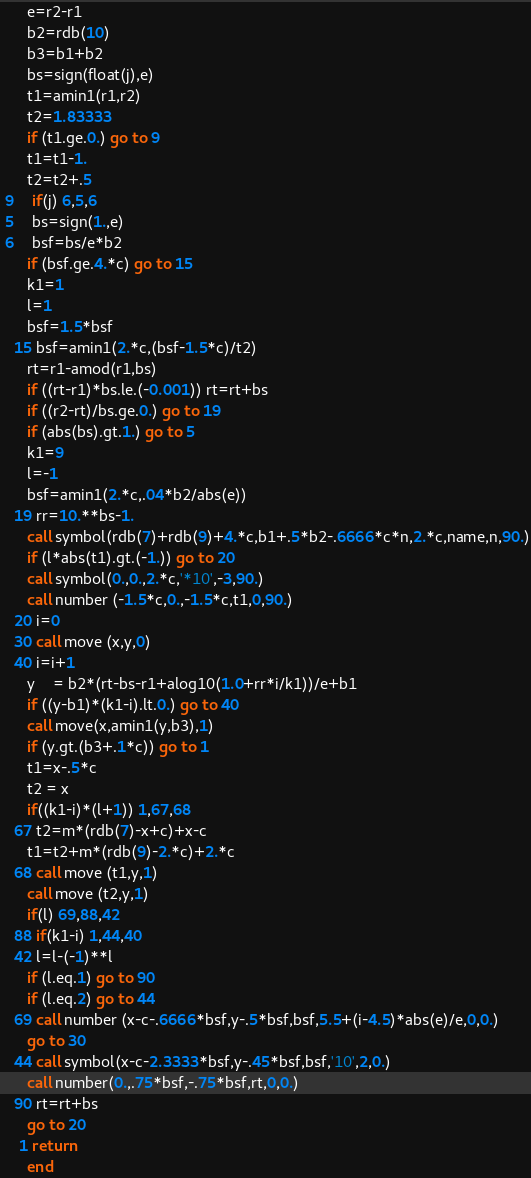Convert code to text. <code><loc_0><loc_0><loc_500><loc_500><_FORTRAN_>      e=r2-r1
      b2=rdb(10)
      b3=b1+b2
      bs=sign(float(j),e)
      t1=amin1(r1,r2)
      t2=1.83333
      if (t1.ge.0.) go to 9
      t1=t1-1.
      t2=t2+.5
 9    if(j) 6,5,6
 5    bs=sign(1.,e)
 6    bsf=bs/e*b2
      if (bsf.ge.4.*c) go to 15
      k1=1
      l=1
      bsf=1.5*bsf
   15 bsf=amin1(2.*c,(bsf-1.5*c)/t2)
      rt=r1-amod(r1,bs)
      if ((rt-r1)*bs.le.(-0.001)) rt=rt+bs
      if ((r2-rt)/bs.ge.0.) go to 19
      if (abs(bs).gt.1.) go to 5
      k1=9
      l=-1
      bsf=amin1(2.*c,.04*b2/abs(e))
   19 rr=10.**bs-1.
      call symbol(rdb(7)+rdb(9)+4.*c,b1+.5*b2-.6666*c*n,2.*c,name,n,90.)
      if (l*abs(t1).gt.(-1.)) go to 20
      call symbol(0.,0.,2.*c,'*10',-3,90.)
      call number (-1.5*c,0.,-1.5*c,t1,0,90.)
   20 i=0
   30 call move (x,y,0)
   40 i=i+1
      y	= b2*(rt-bs-r1+alog10(1.0+rr*i/k1))/e+b1
      if ((y-b1)*(k1-i).lt.0.) go to 40
      call move(x,amin1(y,b3),1)
      if (y.gt.(b3+.1*c)) go to 1
      t1=x-.5*c
      t2 = x
      if((k1-i)*(l+1)) 1,67,68
   67 t2=m*(rdb(7)-x+c)+x-c
      t1=t2+m*(rdb(9)-2.*c)+2.*c
   68 call move (t1,y,1)
      call move (t2,y,1)
      if(l) 69,88,42
   88 if(k1-i) 1,44,40
   42 l=l-(-1)**l
      if (l.eq.1) go to 90
      if (l.eq.2) go to 44
   69 call number (x-c-.6666*bsf,y-.5*bsf,bsf,5.5+(i-4.5)*abs(e)/e,0,0.)
      go to 30
   44 call symbol(x-c-2.3333*bsf,y-.45*bsf,bsf,'10',2,0.)
      call number(0.,.75*bsf,-.75*bsf,rt,0,0.)
   90 rt=rt+bs
      go to 20
    1 return
      end
</code> 